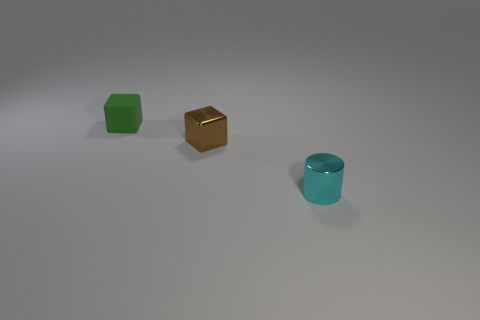Add 1 small metal cylinders. How many objects exist? 4 Subtract all brown blocks. How many blocks are left? 1 Subtract 0 purple cubes. How many objects are left? 3 Subtract all cubes. How many objects are left? 1 Subtract 1 cylinders. How many cylinders are left? 0 Subtract all yellow cubes. Subtract all purple balls. How many cubes are left? 2 Subtract all small green rubber cubes. Subtract all tiny green rubber objects. How many objects are left? 1 Add 2 blocks. How many blocks are left? 4 Add 2 tiny matte cubes. How many tiny matte cubes exist? 3 